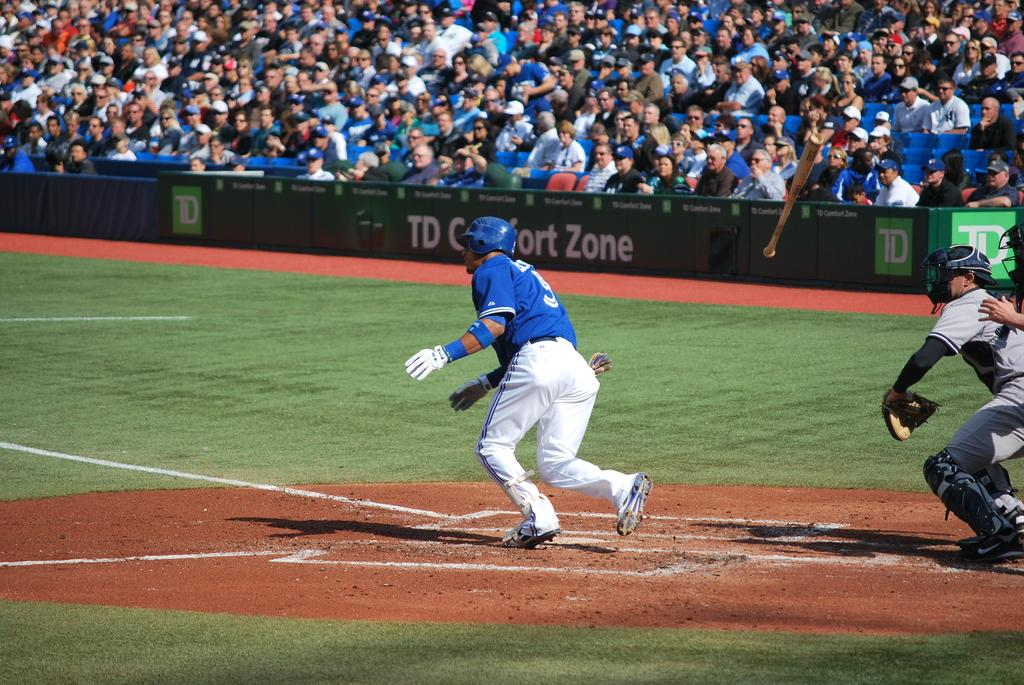Provide a one-sentence caption for the provided image. A baseball player at a packed stadium is running toward first base by a sign that says Comfort Zone. 